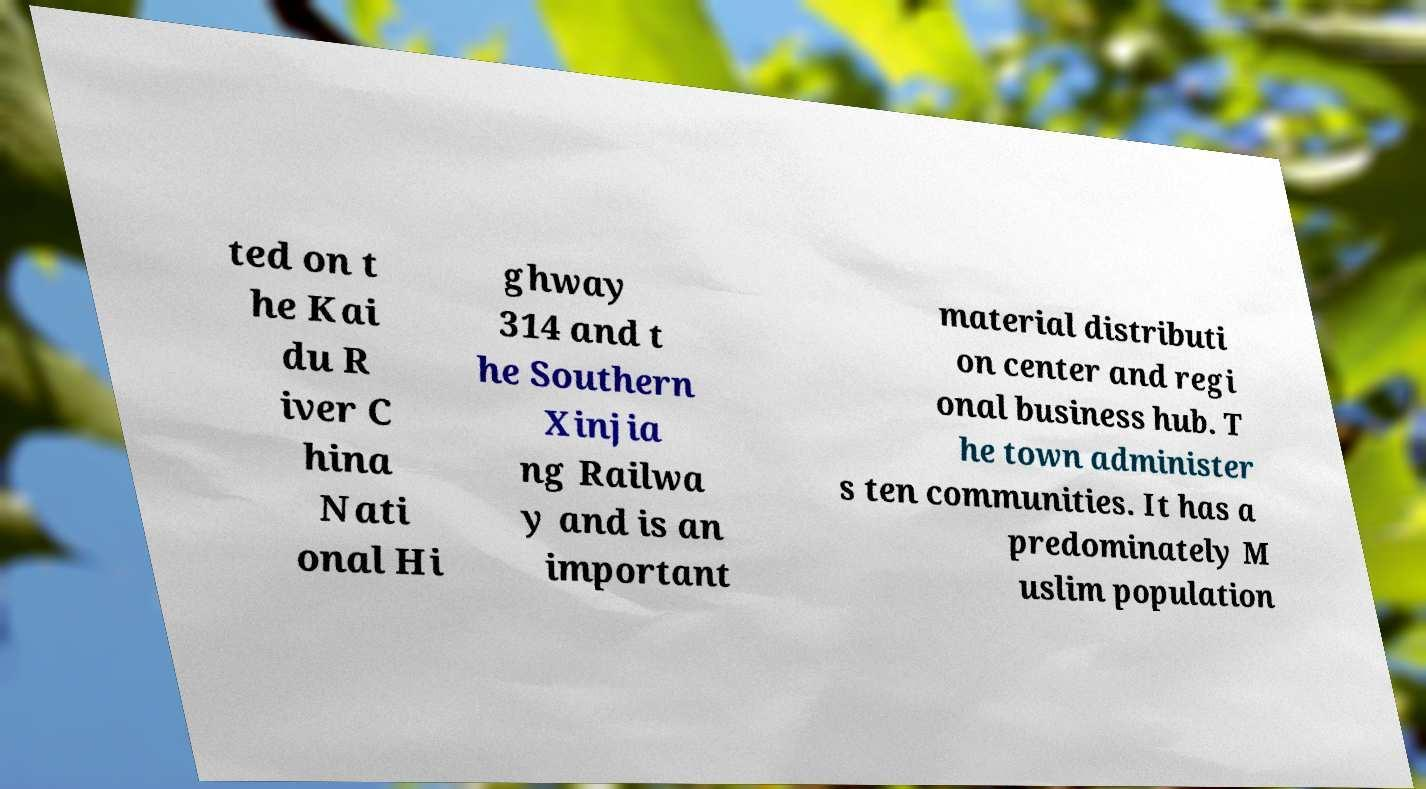Can you accurately transcribe the text from the provided image for me? ted on t he Kai du R iver C hina Nati onal Hi ghway 314 and t he Southern Xinjia ng Railwa y and is an important material distributi on center and regi onal business hub. T he town administer s ten communities. It has a predominately M uslim population 